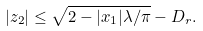<formula> <loc_0><loc_0><loc_500><loc_500>| z _ { 2 } | \leq \sqrt { 2 - | x _ { 1 } | \lambda / \pi } - D _ { r } .</formula> 